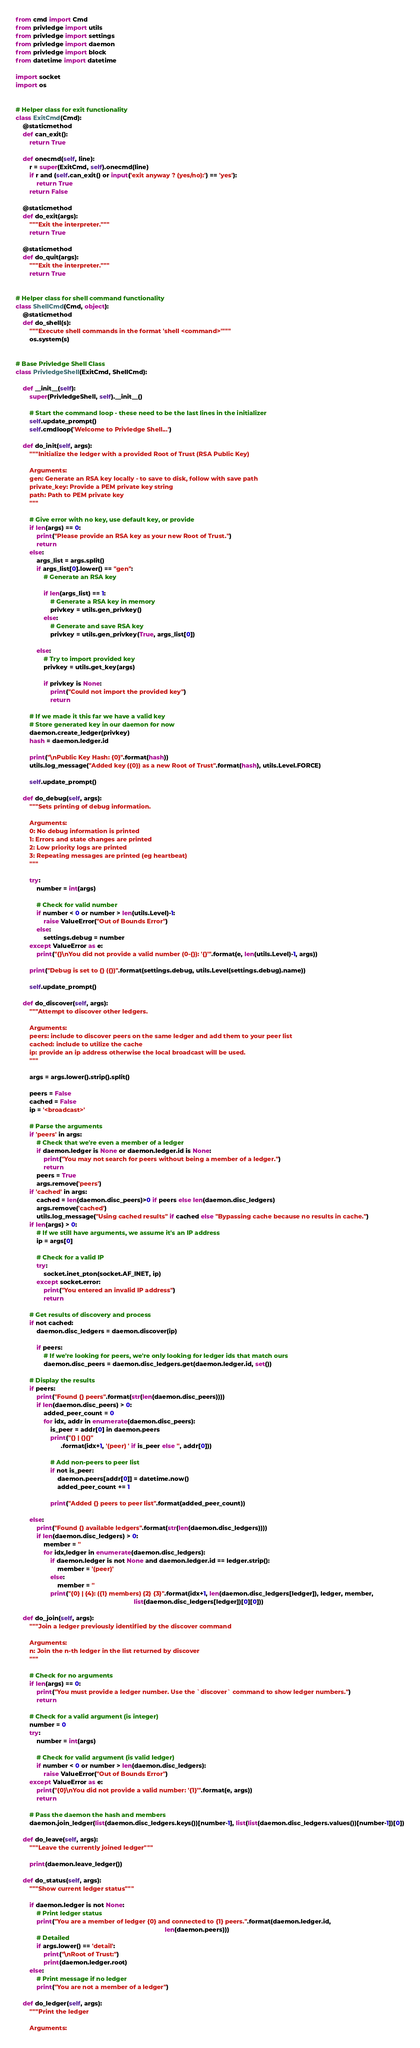Convert code to text. <code><loc_0><loc_0><loc_500><loc_500><_Python_>from cmd import Cmd
from privledge import utils
from privledge import settings
from privledge import daemon
from privledge import block
from datetime import datetime

import socket
import os


# Helper class for exit functionality
class ExitCmd(Cmd):
    @staticmethod
    def can_exit():
        return True

    def onecmd(self, line):
        r = super(ExitCmd, self).onecmd(line)
        if r and (self.can_exit() or input('exit anyway ? (yes/no):') == 'yes'):
            return True
        return False

    @staticmethod
    def do_exit(args):
        """Exit the interpreter."""
        return True

    @staticmethod
    def do_quit(args):
        """Exit the interpreter."""
        return True


# Helper class for shell command functionality
class ShellCmd(Cmd, object):
    @staticmethod
    def do_shell(s):
        """Execute shell commands in the format 'shell <command>'"""
        os.system(s)


# Base Privledge Shell Class
class PrivledgeShell(ExitCmd, ShellCmd):

    def __init__(self):
        super(PrivledgeShell, self).__init__()

        # Start the command loop - these need to be the last lines in the initializer
        self.update_prompt()
        self.cmdloop('Welcome to Privledge Shell...')

    def do_init(self, args):
        """Initialize the ledger with a provided Root of Trust (RSA Public Key)

        Arguments:
        gen: Generate an RSA key locally - to save to disk, follow with save path
        private_key: Provide a PEM private key string
        path: Path to PEM private key
        """

        # Give error with no key, use default key, or provide
        if len(args) == 0:
            print("Please provide an RSA key as your new Root of Trust.")
            return
        else:
            args_list = args.split()
            if args_list[0].lower() == "gen":
                # Generate an RSA key

                if len(args_list) == 1:
                    # Generate a RSA key in memory
                    privkey = utils.gen_privkey()
                else:
                    # Generate and save RSA key
                    privkey = utils.gen_privkey(True, args_list[0])

            else:
                # Try to import provided key
                privkey = utils.get_key(args)

                if privkey is None:
                    print("Could not import the provided key")
                    return

        # If we made it this far we have a valid key
        # Store generated key in our daemon for now
        daemon.create_ledger(privkey)
        hash = daemon.ledger.id

        print("\nPublic Key Hash: {0}".format(hash))
        utils.log_message("Added key ({0}) as a new Root of Trust".format(hash), utils.Level.FORCE)

        self.update_prompt()

    def do_debug(self, args):
        """Sets printing of debug information.

        Arguments:
        0: No debug information is printed
        1: Errors and state changes are printed
        2: Low priority logs are printed
        3: Repeating messages are printed (eg heartbeat)
        """

        try:
            number = int(args)

            # Check for valid number
            if number < 0 or number > len(utils.Level)-1:
                raise ValueError("Out of Bounds Error")
            else:
                settings.debug = number
        except ValueError as e:
            print("{}\nYou did not provide a valid number (0-{}): '{}'".format(e, len(utils.Level)-1, args))

        print("Debug is set to {} ({})".format(settings.debug, utils.Level(settings.debug).name))

        self.update_prompt()

    def do_discover(self, args):
        """Attempt to discover other ledgers.

        Arguments:
        peers: include to discover peers on the same ledger and add them to your peer list
        cached: include to utilize the cache
        ip: provide an ip address otherwise the local broadcast will be used.
        """

        args = args.lower().strip().split()

        peers = False
        cached = False
        ip = '<broadcast>'

        # Parse the arguments
        if 'peers' in args:
            # Check that we're even a member of a ledger
            if daemon.ledger is None or daemon.ledger.id is None:
                print("You may not search for peers without being a member of a ledger.")
                return
            peers = True
            args.remove('peers')
        if 'cached' in args:
            cached = len(daemon.disc_peers)>0 if peers else len(daemon.disc_ledgers)
            args.remove('cached')
            utils.log_message("Using cached results" if cached else "Bypassing cache because no results in cache.")
        if len(args) > 0:
            # If we still have arguments, we assume it's an IP address
            ip = args[0]

            # Check for a valid IP
            try:
                socket.inet_pton(socket.AF_INET, ip)
            except socket.error:
                print("You entered an invalid IP address")
                return

        # Get results of discovery and process
        if not cached:
            daemon.disc_ledgers = daemon.discover(ip)

            if peers:
                # If we're looking for peers, we're only looking for ledger ids that match ours
                daemon.disc_peers = daemon.disc_ledgers.get(daemon.ledger.id, set())

        # Display the results
        if peers:
            print("Found {} peers".format(str(len(daemon.disc_peers))))
            if len(daemon.disc_peers) > 0:
                added_peer_count = 0
                for idx, addr in enumerate(daemon.disc_peers):
                    is_peer = addr[0] in daemon.peers
                    print("{} | {}{}"
                          .format(idx+1, '(peer) ' if is_peer else '', addr[0]))

                    # Add non-peers to peer list
                    if not is_peer:
                        daemon.peers[addr[0]] = datetime.now()
                        added_peer_count += 1

                    print("Added {} peers to peer list".format(added_peer_count))

        else:
            print("Found {} available ledgers".format(str(len(daemon.disc_ledgers))))
            if len(daemon.disc_ledgers) > 0:
                member = ''
                for idx,ledger in enumerate(daemon.disc_ledgers):
                    if daemon.ledger is not None and daemon.ledger.id == ledger.strip():
                        member = '(peer)'
                    else:
                        member = ''
                    print("{0} | {4}: ({1} members) {2} {3}".format(idx+1, len(daemon.disc_ledgers[ledger]), ledger, member,
                                                                    list(daemon.disc_ledgers[ledger])[0][0]))

    def do_join(self, args):
        """Join a ledger previously identified by the discover command

        Arguments:
        n: Join the n-th ledger in the list returned by discover
        """

        # Check for no arguments
        if len(args) == 0:
            print("You must provide a ledger number. Use the `discover` command to show ledger numbers.")
            return

        # Check for a valid argument (is integer)
        number = 0
        try:
            number = int(args)

            # Check for valid argument (is valid ledger)
            if number < 0 or number > len(daemon.disc_ledgers):
                raise ValueError("Out of Bounds Error")
        except ValueError as e:
            print("{0}\nYou did not provide a valid number: '{1}'".format(e, args))
            return

        # Pass the daemon the hash and members
        daemon.join_ledger(list(daemon.disc_ledgers.keys())[number-1], list(list(daemon.disc_ledgers.values())[number-1])[0])

    def do_leave(self, args):
        """Leave the currently joined ledger"""

        print(daemon.leave_ledger())

    def do_status(self, args):
        """Show current ledger status"""

        if daemon.ledger is not None:
            # Print ledger status
            print("You are a member of ledger {0} and connected to {1} peers.".format(daemon.ledger.id,
                                                                                      len(daemon.peers)))
            # Detailed
            if args.lower() == 'detail':
                print("\nRoot of Trust:")
                print(daemon.ledger.root)
        else:
            # Print message if no ledger
            print("You are not a member of a ledger")

    def do_ledger(self, args):
        """Print the ledger

        Arguments:</code> 